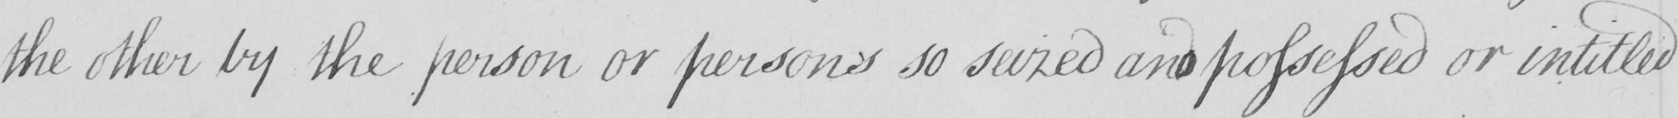Transcribe the text shown in this historical manuscript line. the other by the person or persons so seized and possessed or intitled 